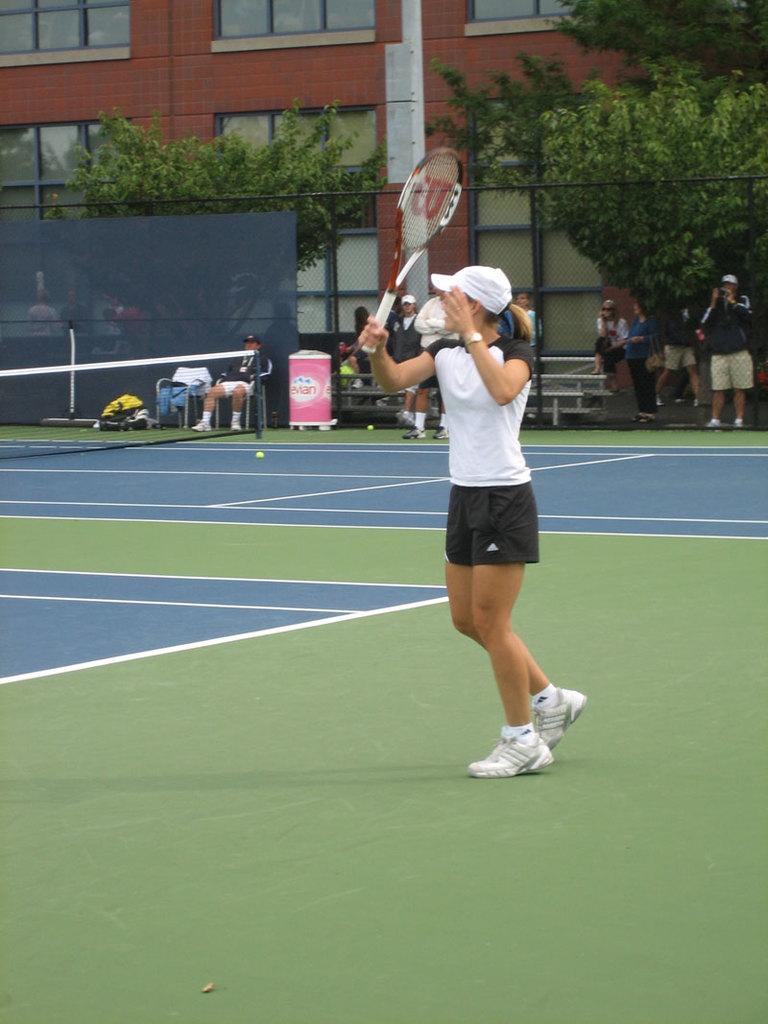Please provide a concise description of this image. In this image we can see a woman holding a racket in her hands is standing in the court. In the background we can see a net, trees, people and building. 